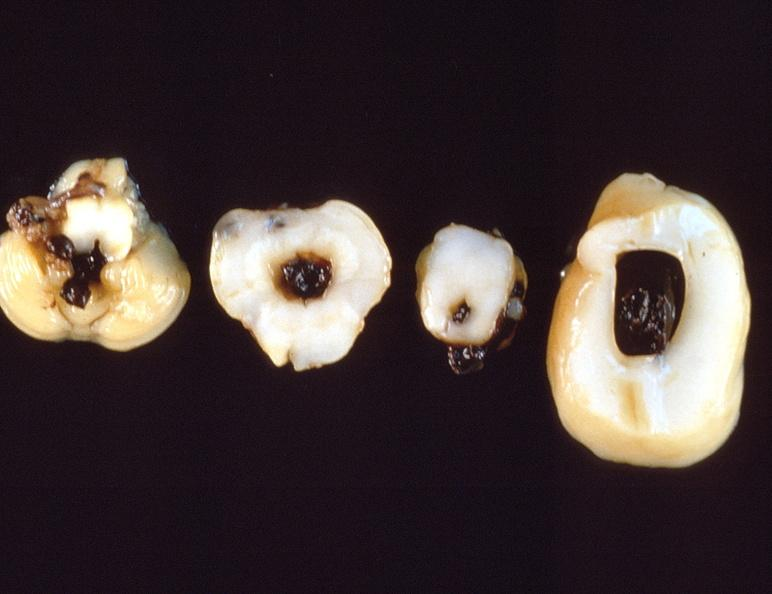s papillary intraductal adenocarcinoma present?
Answer the question using a single word or phrase. No 